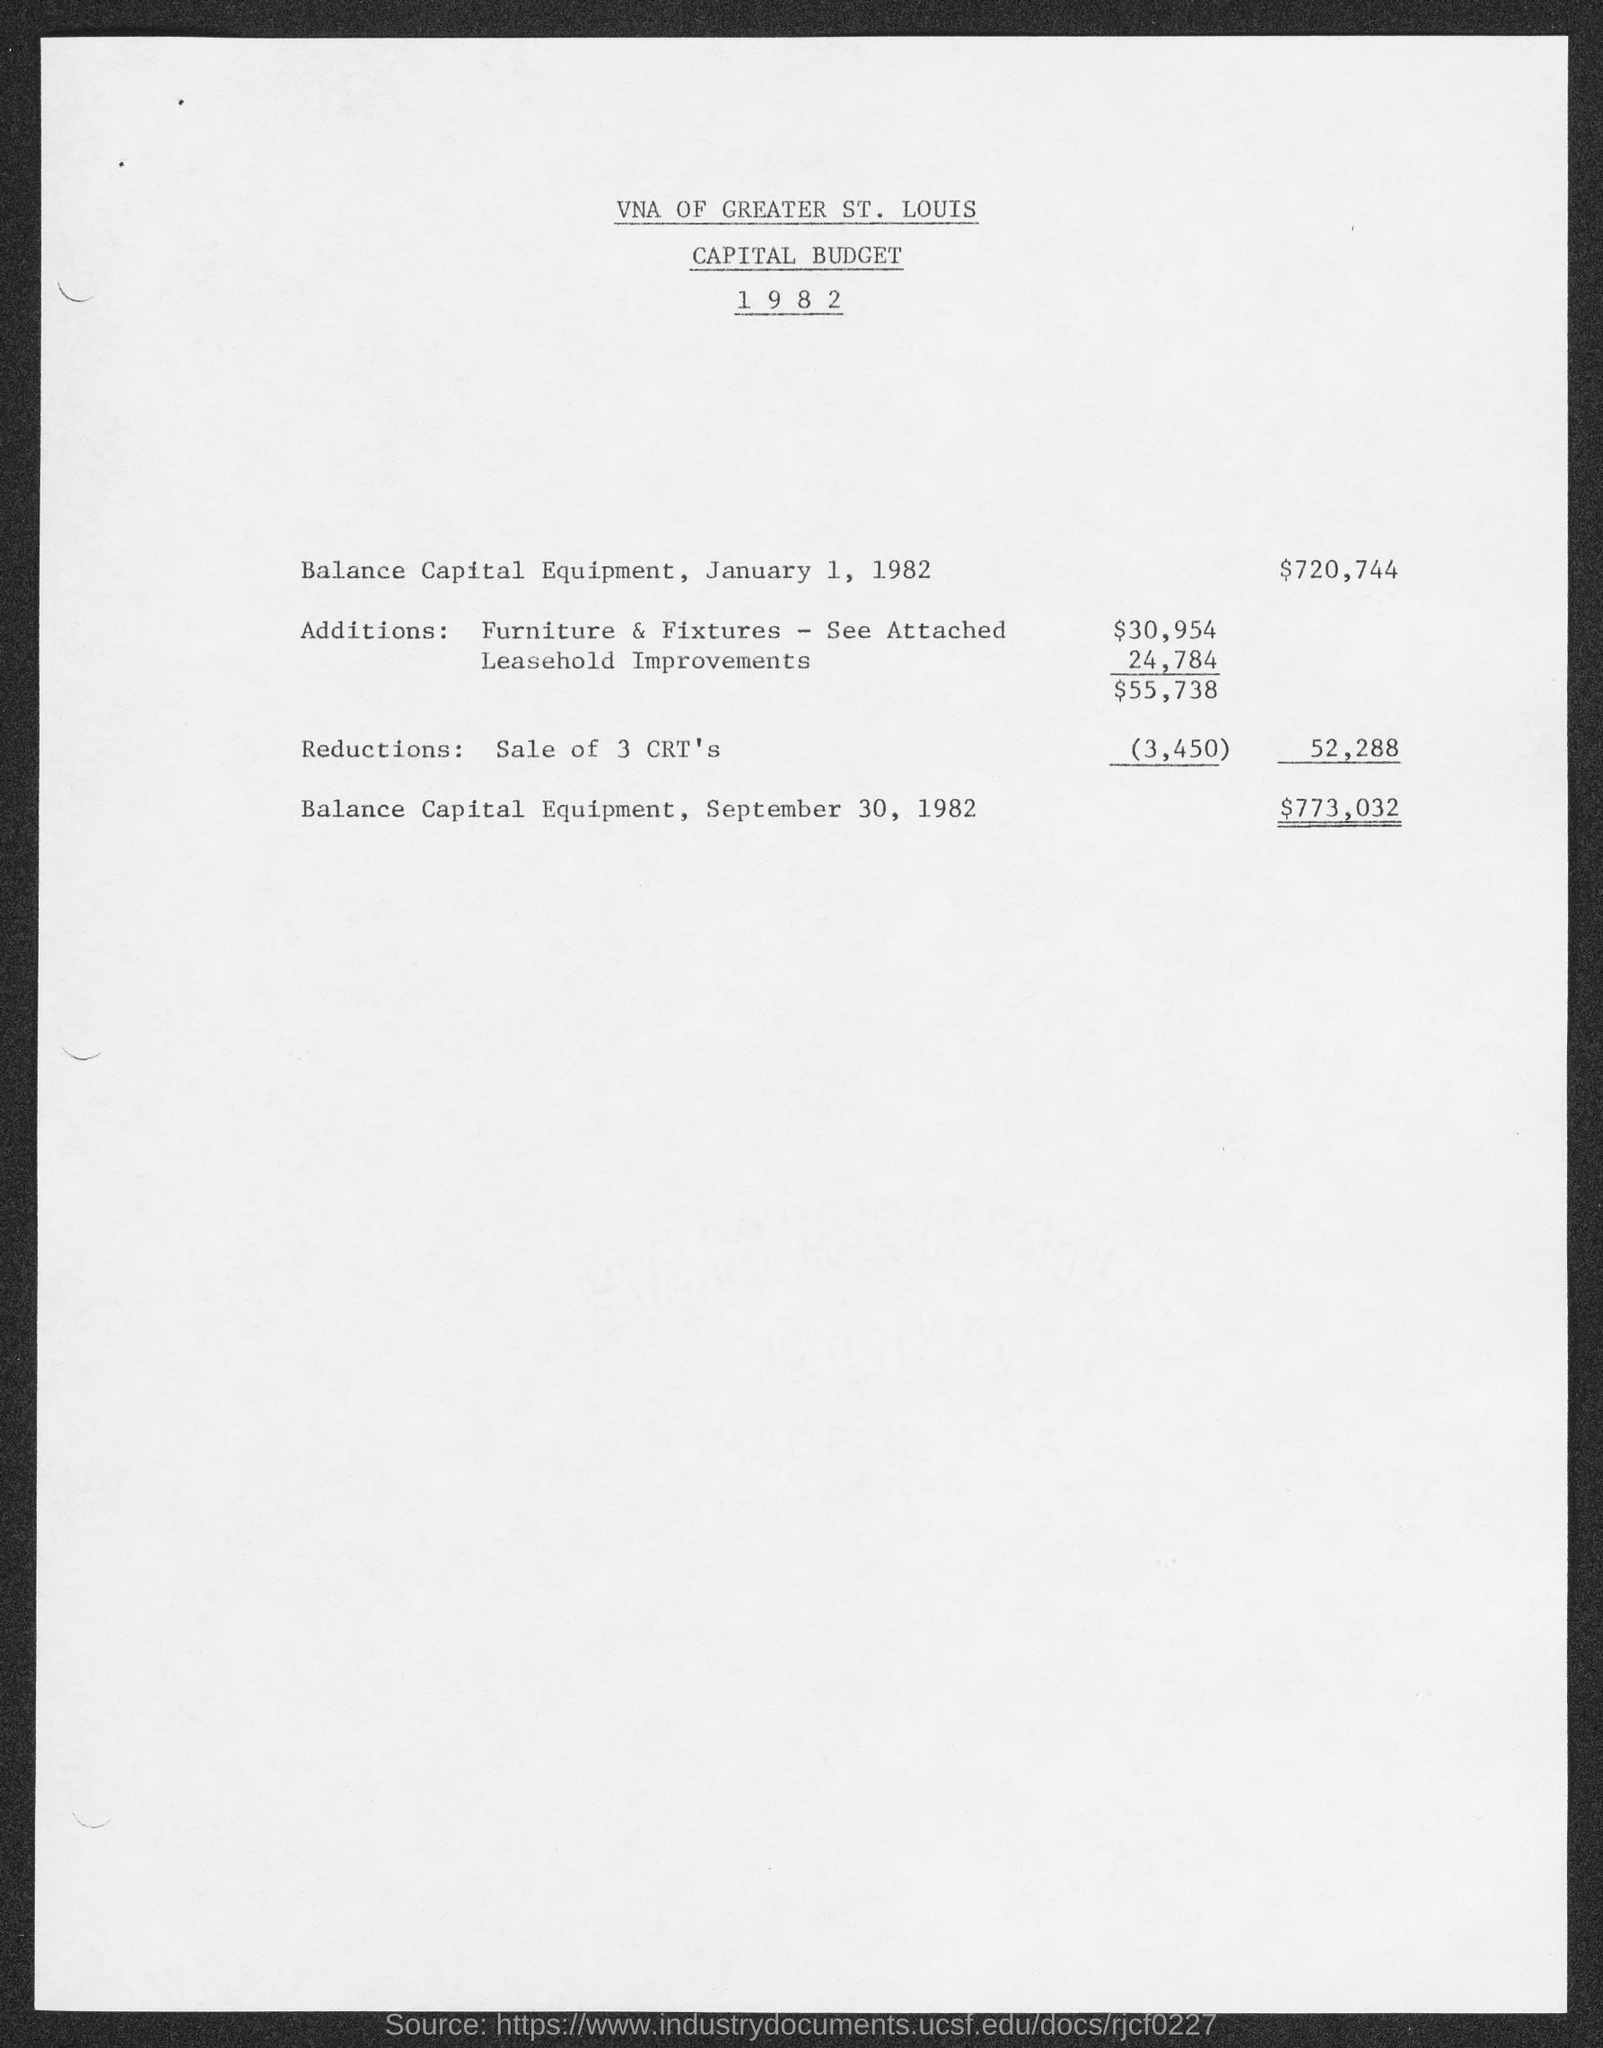Outline some significant characteristics in this image. On January 1, 1982, the balance of capital equipment was $720,744. On September 30, 1982, the balance of capital equipment was $773,032. 